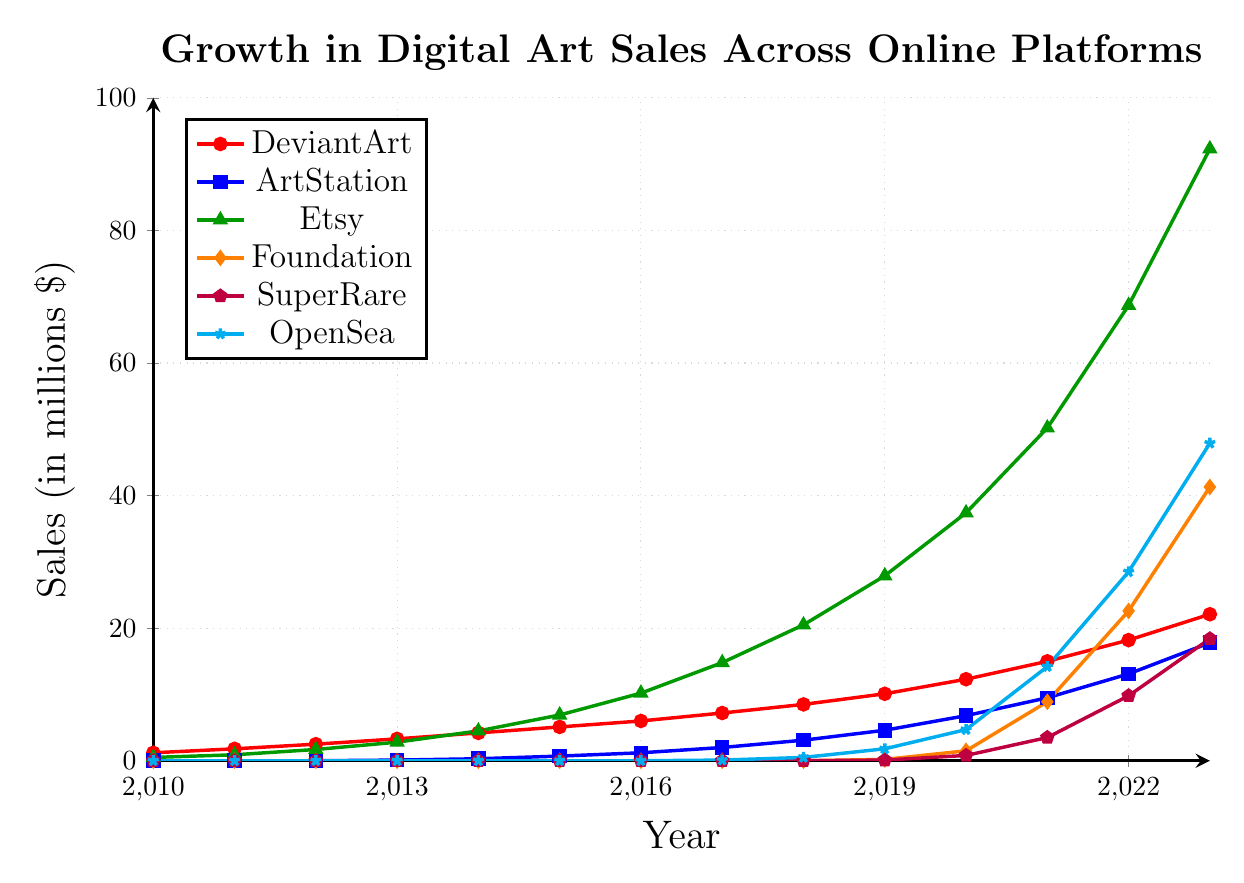What was the sales difference between Etsy and Foundation in 2021? In 2021, Etsy had 50.2 million dollars in sales while Foundation had 8.9 million dollars. The difference is calculated as 50.2 - 8.9 = 41.3 million dollars.
Answer: 41.3 million dollars Which platform had the highest sales in 2023? From the figure, Etsy had the highest sales in 2023 with 92.3 million dollars.
Answer: Etsy Between which years did ArtStation's sales increase the most? ArtStation experienced the largest increase from 2021 to 2022, where the sales went from 9.5 million dollars to 13.1 million dollars. The increase is 13.1 - 9.5 = 3.6 million dollars.
Answer: 2021 to 2022 Which platform had zero sales up to 2019 but showed sales in 2020? Foundation had zero sales up to 2019 and showed 1.5 million dollars in sales in 2020.
Answer: Foundation What was the average sales for OpenSea in the years 2019, 2020, and 2021? The sales for OpenSea in 2019, 2020, and 2021 were 1.8, 4.7, and 14.2 million dollars respectively. The average is calculated as (1.8 + 4.7 + 14.2) / 3 = 20.7 / 3 = 6.9 million dollars.
Answer: 6.9 million dollars Which two platforms had sales figures above 20 million dollars in 2023? In 2023, both Etsy (92.3) and OpenSea (47.9) had sales above 20 million dollars.
Answer: Etsy, OpenSea How many platforms had sales of at least 10 million dollars in 2021? In 2021, Etsy (50.2), Foundation (8.9), SuperRare (3.5), and OpenSea (14.2) were shown. Out of these, Etsy and OpenSea had sales of at least 10 million dollars.
Answer: 2 What is the total sales for DeviantArt from 2010 to 2023? Summing up the sales for DeviantArt from 2010 to 2023: 1.2 + 1.8 + 2.5 + 3.3 + 4.2 + 5.1 + 6.0 + 7.2 + 8.5 + 10.1 + 12.3 + 15.0 + 18.2 + 22.1 = 117.5 million dollars.
Answer: 117.5 million dollars Which year's sales for SuperRare were equal to Foundation's sales in 2020? In 2020, Foundation had sales of 1.5 million dollars. SuperRare had equivalent sales in the same year, which was also 1.5 million dollars.
Answer: 2020 